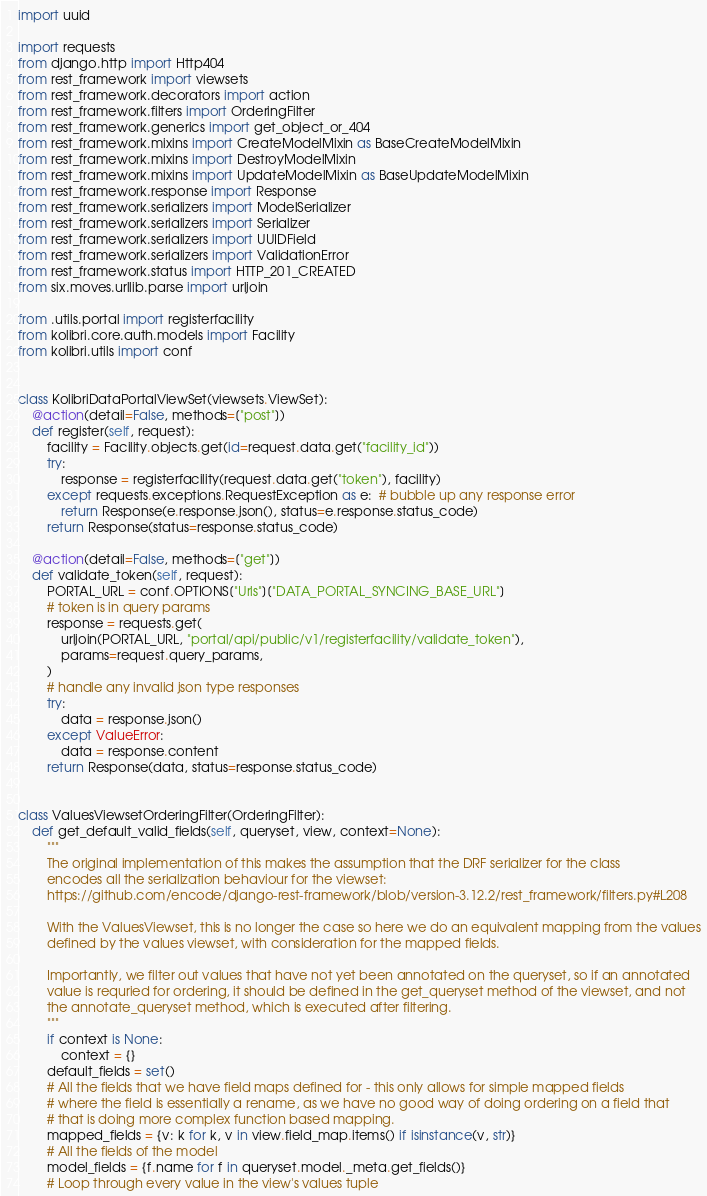<code> <loc_0><loc_0><loc_500><loc_500><_Python_>import uuid

import requests
from django.http import Http404
from rest_framework import viewsets
from rest_framework.decorators import action
from rest_framework.filters import OrderingFilter
from rest_framework.generics import get_object_or_404
from rest_framework.mixins import CreateModelMixin as BaseCreateModelMixin
from rest_framework.mixins import DestroyModelMixin
from rest_framework.mixins import UpdateModelMixin as BaseUpdateModelMixin
from rest_framework.response import Response
from rest_framework.serializers import ModelSerializer
from rest_framework.serializers import Serializer
from rest_framework.serializers import UUIDField
from rest_framework.serializers import ValidationError
from rest_framework.status import HTTP_201_CREATED
from six.moves.urllib.parse import urljoin

from .utils.portal import registerfacility
from kolibri.core.auth.models import Facility
from kolibri.utils import conf


class KolibriDataPortalViewSet(viewsets.ViewSet):
    @action(detail=False, methods=["post"])
    def register(self, request):
        facility = Facility.objects.get(id=request.data.get("facility_id"))
        try:
            response = registerfacility(request.data.get("token"), facility)
        except requests.exceptions.RequestException as e:  # bubble up any response error
            return Response(e.response.json(), status=e.response.status_code)
        return Response(status=response.status_code)

    @action(detail=False, methods=["get"])
    def validate_token(self, request):
        PORTAL_URL = conf.OPTIONS["Urls"]["DATA_PORTAL_SYNCING_BASE_URL"]
        # token is in query params
        response = requests.get(
            urljoin(PORTAL_URL, "portal/api/public/v1/registerfacility/validate_token"),
            params=request.query_params,
        )
        # handle any invalid json type responses
        try:
            data = response.json()
        except ValueError:
            data = response.content
        return Response(data, status=response.status_code)


class ValuesViewsetOrderingFilter(OrderingFilter):
    def get_default_valid_fields(self, queryset, view, context=None):
        """
        The original implementation of this makes the assumption that the DRF serializer for the class
        encodes all the serialization behaviour for the viewset:
        https://github.com/encode/django-rest-framework/blob/version-3.12.2/rest_framework/filters.py#L208

        With the ValuesViewset, this is no longer the case so here we do an equivalent mapping from the values
        defined by the values viewset, with consideration for the mapped fields.

        Importantly, we filter out values that have not yet been annotated on the queryset, so if an annotated
        value is requried for ordering, it should be defined in the get_queryset method of the viewset, and not
        the annotate_queryset method, which is executed after filtering.
        """
        if context is None:
            context = {}
        default_fields = set()
        # All the fields that we have field maps defined for - this only allows for simple mapped fields
        # where the field is essentially a rename, as we have no good way of doing ordering on a field that
        # that is doing more complex function based mapping.
        mapped_fields = {v: k for k, v in view.field_map.items() if isinstance(v, str)}
        # All the fields of the model
        model_fields = {f.name for f in queryset.model._meta.get_fields()}
        # Loop through every value in the view's values tuple</code> 